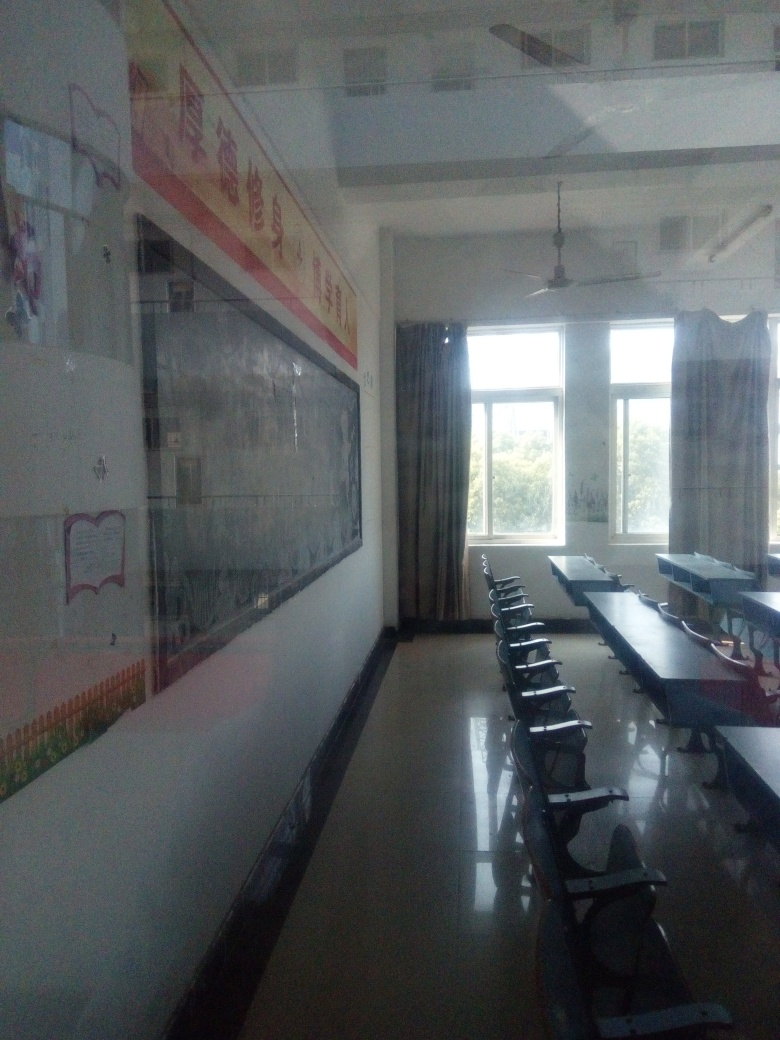What kind of room is shown in the image, and how can you tell? The image shows a classroom, identifiable by the rows of desks and chairs facing towards a whiteboard at the front. Additionally, educational posters on the walls further indicate its use for teaching and learning. 